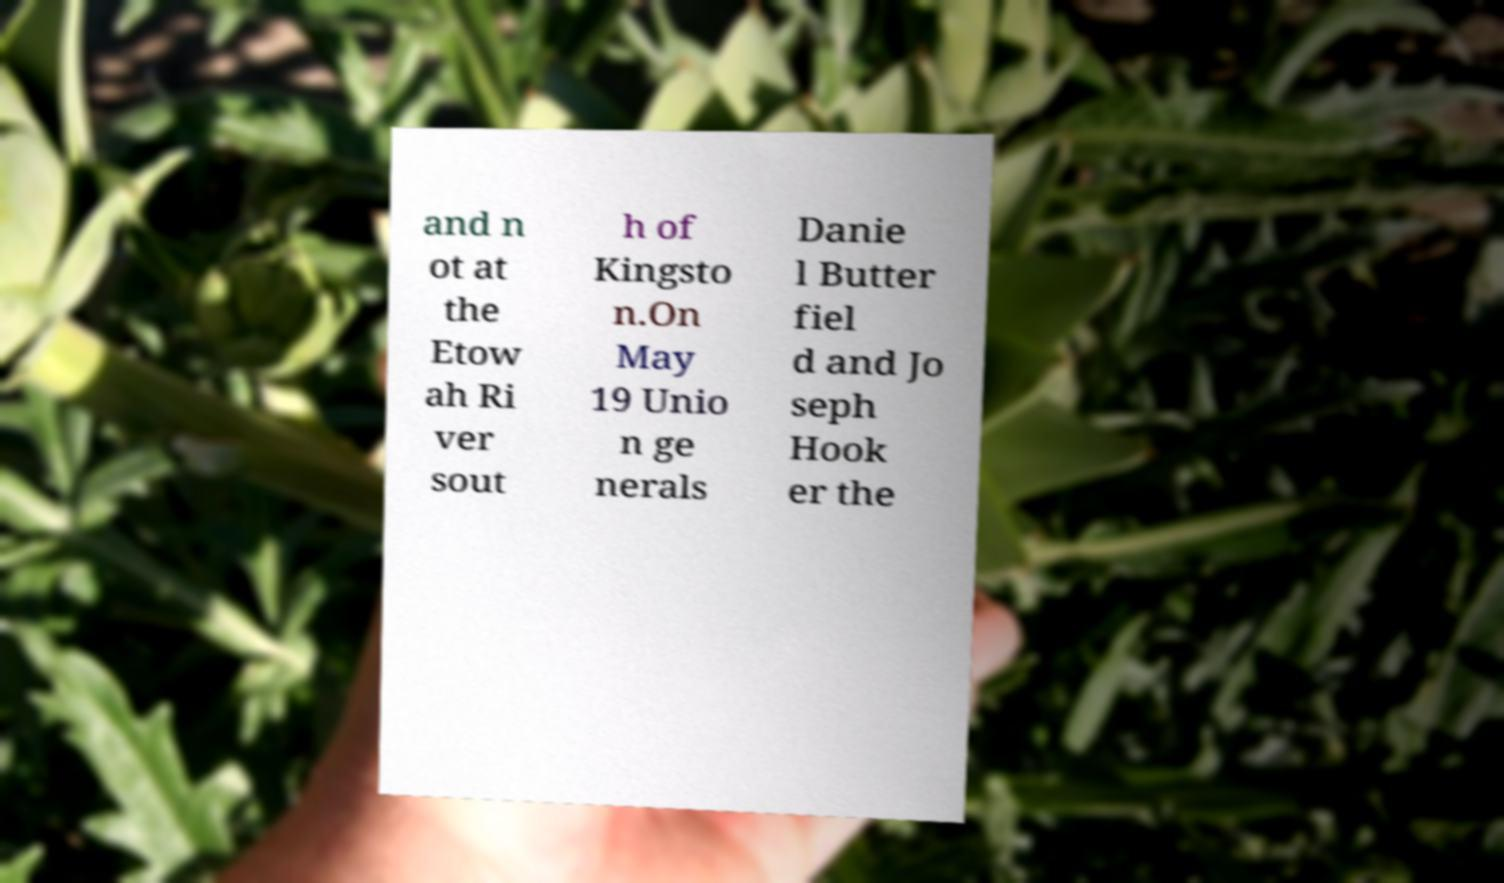Please read and relay the text visible in this image. What does it say? and n ot at the Etow ah Ri ver sout h of Kingsto n.On May 19 Unio n ge nerals Danie l Butter fiel d and Jo seph Hook er the 